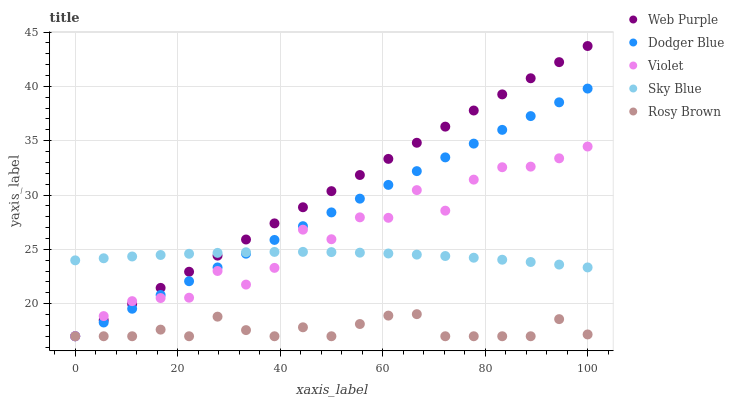Does Rosy Brown have the minimum area under the curve?
Answer yes or no. Yes. Does Web Purple have the maximum area under the curve?
Answer yes or no. Yes. Does Web Purple have the minimum area under the curve?
Answer yes or no. No. Does Rosy Brown have the maximum area under the curve?
Answer yes or no. No. Is Web Purple the smoothest?
Answer yes or no. Yes. Is Violet the roughest?
Answer yes or no. Yes. Is Rosy Brown the smoothest?
Answer yes or no. No. Is Rosy Brown the roughest?
Answer yes or no. No. Does Web Purple have the lowest value?
Answer yes or no. Yes. Does Web Purple have the highest value?
Answer yes or no. Yes. Does Rosy Brown have the highest value?
Answer yes or no. No. Is Rosy Brown less than Sky Blue?
Answer yes or no. Yes. Is Sky Blue greater than Rosy Brown?
Answer yes or no. Yes. Does Violet intersect Web Purple?
Answer yes or no. Yes. Is Violet less than Web Purple?
Answer yes or no. No. Is Violet greater than Web Purple?
Answer yes or no. No. Does Rosy Brown intersect Sky Blue?
Answer yes or no. No. 